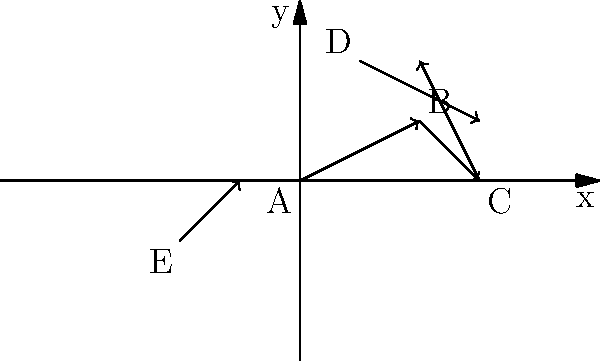In the diagram above, imagine each vector represents the movement of a soccer player on the pitch. Which player's movement contributes the most to moving the team forward (in the positive x-direction) during this particular play? To determine which player's movement contributes the most to moving the team forward (positive x-direction), we need to analyze the x-component of each vector:

1. Vector A (starting at (0,0)): 
   x-component = 2

2. Vector B (starting at (2,1)):
   x-component = 1

3. Vector C (starting at (3,0)):
   x-component = -1

4. Vector D (starting at (1,2)):
   x-component = 2

5. Vector E (starting at (-2,-1)):
   x-component = 1

The largest positive x-component is 2, which occurs for both Vector A and Vector D. However, Vector A starts at the origin (0,0), which can be considered as the initial position of the player. Therefore, player A's movement contributes the most to moving the team forward.

This analysis is similar to how an experienced soccer enthusiast might observe player movements on the field, focusing on who is making the most progress towards the opponent's goal.
Answer: Player A 